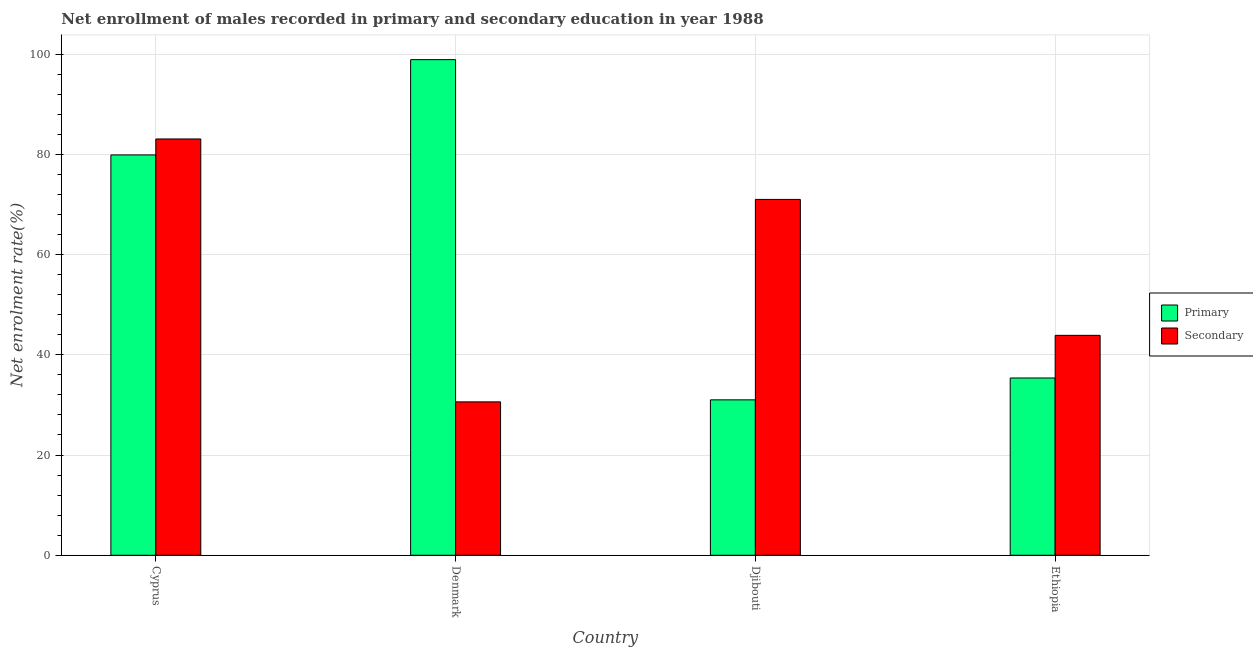How many different coloured bars are there?
Your answer should be very brief. 2. How many groups of bars are there?
Provide a succinct answer. 4. Are the number of bars per tick equal to the number of legend labels?
Your response must be concise. Yes. Are the number of bars on each tick of the X-axis equal?
Provide a succinct answer. Yes. How many bars are there on the 2nd tick from the left?
Offer a very short reply. 2. How many bars are there on the 3rd tick from the right?
Make the answer very short. 2. What is the label of the 2nd group of bars from the left?
Your answer should be very brief. Denmark. What is the enrollment rate in secondary education in Djibouti?
Keep it short and to the point. 71. Across all countries, what is the maximum enrollment rate in primary education?
Provide a short and direct response. 98.88. Across all countries, what is the minimum enrollment rate in secondary education?
Ensure brevity in your answer.  30.6. In which country was the enrollment rate in primary education maximum?
Provide a succinct answer. Denmark. In which country was the enrollment rate in primary education minimum?
Provide a succinct answer. Djibouti. What is the total enrollment rate in secondary education in the graph?
Your answer should be compact. 228.53. What is the difference between the enrollment rate in secondary education in Denmark and that in Djibouti?
Your answer should be very brief. -40.39. What is the difference between the enrollment rate in secondary education in Denmark and the enrollment rate in primary education in Cyprus?
Keep it short and to the point. -49.27. What is the average enrollment rate in secondary education per country?
Provide a succinct answer. 57.13. What is the difference between the enrollment rate in primary education and enrollment rate in secondary education in Ethiopia?
Offer a very short reply. -8.51. In how many countries, is the enrollment rate in primary education greater than 36 %?
Provide a short and direct response. 2. What is the ratio of the enrollment rate in secondary education in Denmark to that in Ethiopia?
Provide a succinct answer. 0.7. Is the enrollment rate in secondary education in Denmark less than that in Djibouti?
Your response must be concise. Yes. Is the difference between the enrollment rate in secondary education in Djibouti and Ethiopia greater than the difference between the enrollment rate in primary education in Djibouti and Ethiopia?
Keep it short and to the point. Yes. What is the difference between the highest and the second highest enrollment rate in primary education?
Provide a short and direct response. 19.01. What is the difference between the highest and the lowest enrollment rate in primary education?
Make the answer very short. 67.88. What does the 2nd bar from the left in Cyprus represents?
Offer a very short reply. Secondary. What does the 1st bar from the right in Ethiopia represents?
Make the answer very short. Secondary. How many bars are there?
Keep it short and to the point. 8. How many countries are there in the graph?
Give a very brief answer. 4. Are the values on the major ticks of Y-axis written in scientific E-notation?
Give a very brief answer. No. Does the graph contain any zero values?
Your answer should be very brief. No. Does the graph contain grids?
Your answer should be very brief. Yes. How many legend labels are there?
Your response must be concise. 2. How are the legend labels stacked?
Ensure brevity in your answer.  Vertical. What is the title of the graph?
Make the answer very short. Net enrollment of males recorded in primary and secondary education in year 1988. What is the label or title of the Y-axis?
Your answer should be very brief. Net enrolment rate(%). What is the Net enrolment rate(%) in Primary in Cyprus?
Offer a terse response. 79.87. What is the Net enrolment rate(%) of Secondary in Cyprus?
Your answer should be very brief. 83.06. What is the Net enrolment rate(%) in Primary in Denmark?
Give a very brief answer. 98.88. What is the Net enrolment rate(%) of Secondary in Denmark?
Offer a terse response. 30.6. What is the Net enrolment rate(%) of Primary in Djibouti?
Provide a succinct answer. 31.01. What is the Net enrolment rate(%) of Secondary in Djibouti?
Provide a short and direct response. 71. What is the Net enrolment rate(%) in Primary in Ethiopia?
Provide a short and direct response. 35.37. What is the Net enrolment rate(%) of Secondary in Ethiopia?
Offer a very short reply. 43.87. Across all countries, what is the maximum Net enrolment rate(%) of Primary?
Make the answer very short. 98.88. Across all countries, what is the maximum Net enrolment rate(%) of Secondary?
Offer a terse response. 83.06. Across all countries, what is the minimum Net enrolment rate(%) in Primary?
Offer a terse response. 31.01. Across all countries, what is the minimum Net enrolment rate(%) of Secondary?
Provide a short and direct response. 30.6. What is the total Net enrolment rate(%) in Primary in the graph?
Your answer should be very brief. 245.13. What is the total Net enrolment rate(%) in Secondary in the graph?
Offer a terse response. 228.53. What is the difference between the Net enrolment rate(%) of Primary in Cyprus and that in Denmark?
Offer a terse response. -19.01. What is the difference between the Net enrolment rate(%) of Secondary in Cyprus and that in Denmark?
Offer a very short reply. 52.45. What is the difference between the Net enrolment rate(%) of Primary in Cyprus and that in Djibouti?
Give a very brief answer. 48.87. What is the difference between the Net enrolment rate(%) in Secondary in Cyprus and that in Djibouti?
Your answer should be compact. 12.06. What is the difference between the Net enrolment rate(%) in Primary in Cyprus and that in Ethiopia?
Provide a succinct answer. 44.51. What is the difference between the Net enrolment rate(%) of Secondary in Cyprus and that in Ethiopia?
Give a very brief answer. 39.18. What is the difference between the Net enrolment rate(%) in Primary in Denmark and that in Djibouti?
Provide a short and direct response. 67.88. What is the difference between the Net enrolment rate(%) of Secondary in Denmark and that in Djibouti?
Give a very brief answer. -40.39. What is the difference between the Net enrolment rate(%) of Primary in Denmark and that in Ethiopia?
Ensure brevity in your answer.  63.51. What is the difference between the Net enrolment rate(%) of Secondary in Denmark and that in Ethiopia?
Provide a short and direct response. -13.27. What is the difference between the Net enrolment rate(%) in Primary in Djibouti and that in Ethiopia?
Ensure brevity in your answer.  -4.36. What is the difference between the Net enrolment rate(%) of Secondary in Djibouti and that in Ethiopia?
Offer a very short reply. 27.12. What is the difference between the Net enrolment rate(%) of Primary in Cyprus and the Net enrolment rate(%) of Secondary in Denmark?
Your answer should be compact. 49.27. What is the difference between the Net enrolment rate(%) of Primary in Cyprus and the Net enrolment rate(%) of Secondary in Djibouti?
Ensure brevity in your answer.  8.88. What is the difference between the Net enrolment rate(%) in Primary in Cyprus and the Net enrolment rate(%) in Secondary in Ethiopia?
Ensure brevity in your answer.  36. What is the difference between the Net enrolment rate(%) in Primary in Denmark and the Net enrolment rate(%) in Secondary in Djibouti?
Offer a very short reply. 27.89. What is the difference between the Net enrolment rate(%) in Primary in Denmark and the Net enrolment rate(%) in Secondary in Ethiopia?
Provide a succinct answer. 55.01. What is the difference between the Net enrolment rate(%) of Primary in Djibouti and the Net enrolment rate(%) of Secondary in Ethiopia?
Ensure brevity in your answer.  -12.87. What is the average Net enrolment rate(%) of Primary per country?
Your response must be concise. 61.28. What is the average Net enrolment rate(%) of Secondary per country?
Offer a very short reply. 57.13. What is the difference between the Net enrolment rate(%) of Primary and Net enrolment rate(%) of Secondary in Cyprus?
Your answer should be compact. -3.18. What is the difference between the Net enrolment rate(%) of Primary and Net enrolment rate(%) of Secondary in Denmark?
Provide a succinct answer. 68.28. What is the difference between the Net enrolment rate(%) of Primary and Net enrolment rate(%) of Secondary in Djibouti?
Ensure brevity in your answer.  -39.99. What is the difference between the Net enrolment rate(%) in Primary and Net enrolment rate(%) in Secondary in Ethiopia?
Make the answer very short. -8.51. What is the ratio of the Net enrolment rate(%) in Primary in Cyprus to that in Denmark?
Provide a succinct answer. 0.81. What is the ratio of the Net enrolment rate(%) of Secondary in Cyprus to that in Denmark?
Give a very brief answer. 2.71. What is the ratio of the Net enrolment rate(%) in Primary in Cyprus to that in Djibouti?
Offer a very short reply. 2.58. What is the ratio of the Net enrolment rate(%) of Secondary in Cyprus to that in Djibouti?
Give a very brief answer. 1.17. What is the ratio of the Net enrolment rate(%) of Primary in Cyprus to that in Ethiopia?
Give a very brief answer. 2.26. What is the ratio of the Net enrolment rate(%) of Secondary in Cyprus to that in Ethiopia?
Your answer should be compact. 1.89. What is the ratio of the Net enrolment rate(%) in Primary in Denmark to that in Djibouti?
Make the answer very short. 3.19. What is the ratio of the Net enrolment rate(%) of Secondary in Denmark to that in Djibouti?
Ensure brevity in your answer.  0.43. What is the ratio of the Net enrolment rate(%) in Primary in Denmark to that in Ethiopia?
Provide a succinct answer. 2.8. What is the ratio of the Net enrolment rate(%) of Secondary in Denmark to that in Ethiopia?
Give a very brief answer. 0.7. What is the ratio of the Net enrolment rate(%) in Primary in Djibouti to that in Ethiopia?
Your answer should be very brief. 0.88. What is the ratio of the Net enrolment rate(%) of Secondary in Djibouti to that in Ethiopia?
Make the answer very short. 1.62. What is the difference between the highest and the second highest Net enrolment rate(%) in Primary?
Offer a terse response. 19.01. What is the difference between the highest and the second highest Net enrolment rate(%) in Secondary?
Ensure brevity in your answer.  12.06. What is the difference between the highest and the lowest Net enrolment rate(%) of Primary?
Give a very brief answer. 67.88. What is the difference between the highest and the lowest Net enrolment rate(%) of Secondary?
Make the answer very short. 52.45. 